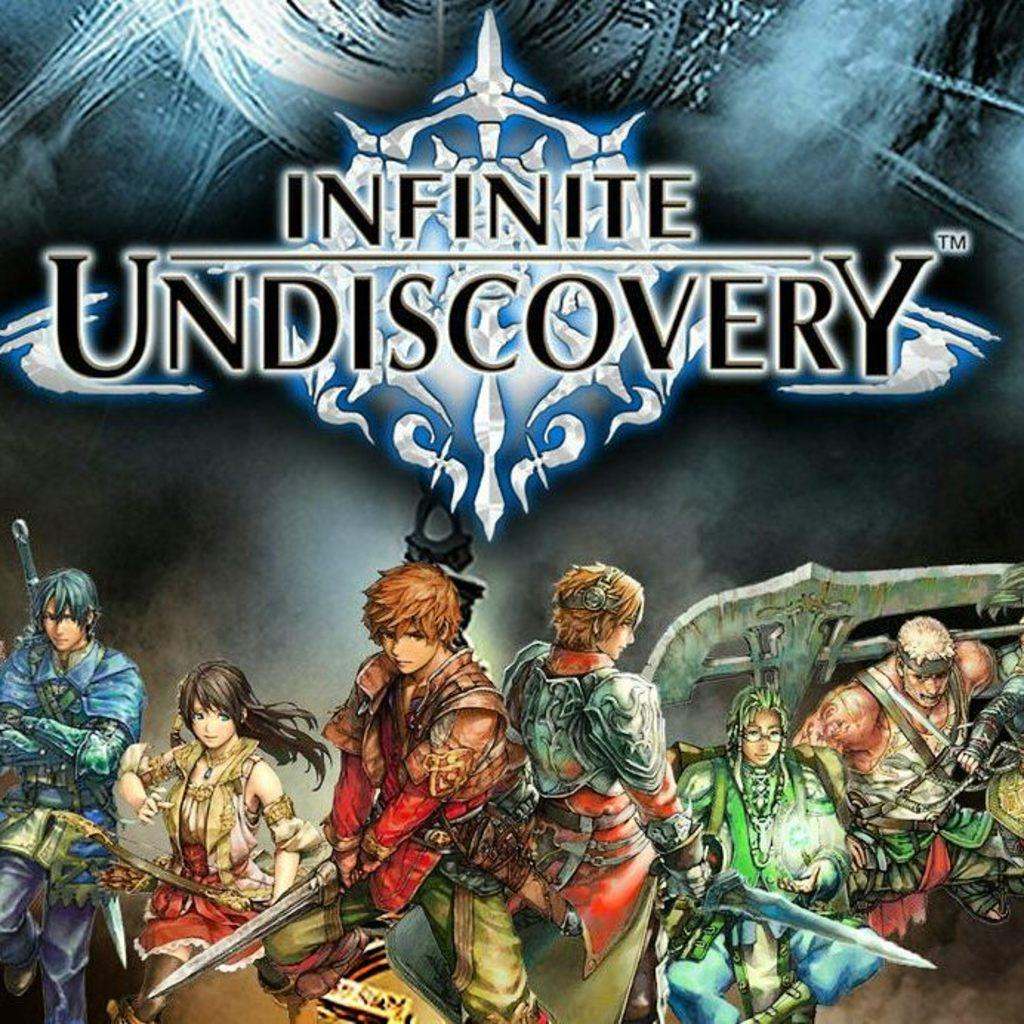<image>
Present a compact description of the photo's key features. A cover for Infinite Undiscovery action role-playing game 